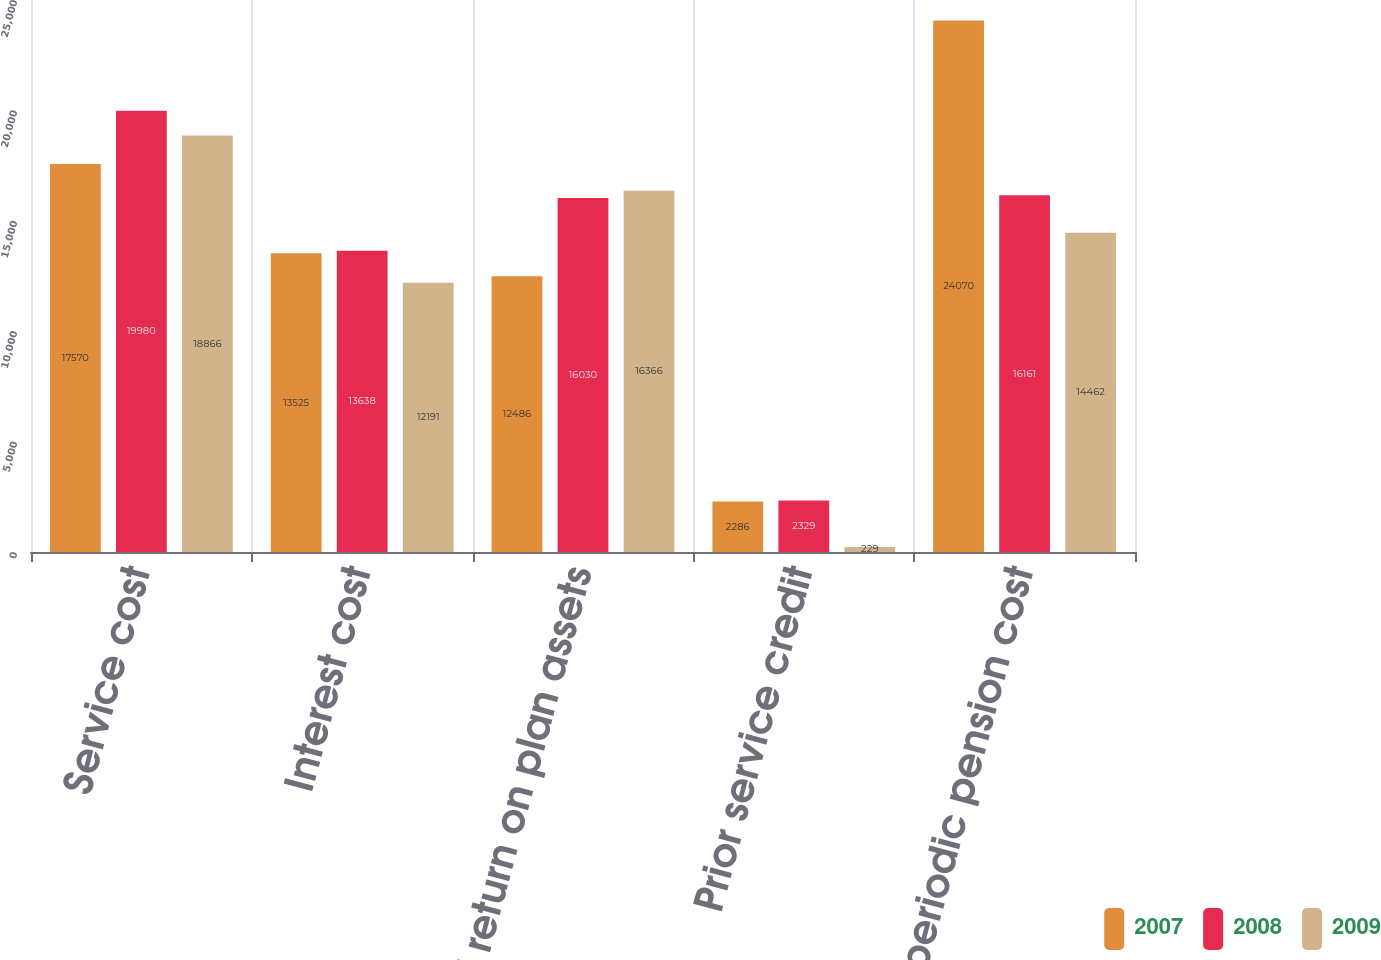<chart> <loc_0><loc_0><loc_500><loc_500><stacked_bar_chart><ecel><fcel>Service cost<fcel>Interest cost<fcel>Expected return on plan assets<fcel>Prior service credit<fcel>Net periodic pension cost<nl><fcel>2007<fcel>17570<fcel>13525<fcel>12486<fcel>2286<fcel>24070<nl><fcel>2008<fcel>19980<fcel>13638<fcel>16030<fcel>2329<fcel>16161<nl><fcel>2009<fcel>18866<fcel>12191<fcel>16366<fcel>229<fcel>14462<nl></chart> 